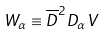Convert formula to latex. <formula><loc_0><loc_0><loc_500><loc_500>W _ { \alpha } \equiv \overline { D } ^ { 2 } D _ { \alpha } V</formula> 